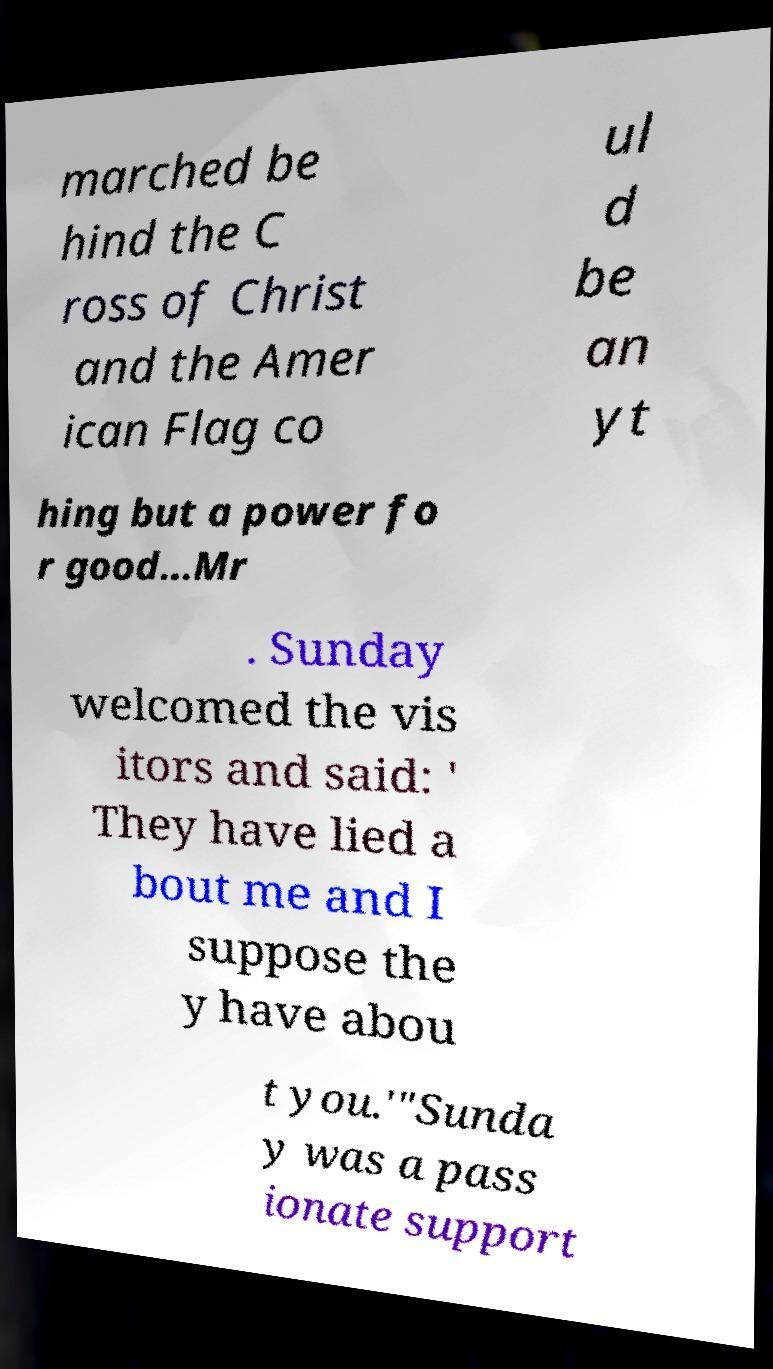For documentation purposes, I need the text within this image transcribed. Could you provide that? marched be hind the C ross of Christ and the Amer ican Flag co ul d be an yt hing but a power fo r good...Mr . Sunday welcomed the vis itors and said: ' They have lied a bout me and I suppose the y have abou t you.'"Sunda y was a pass ionate support 